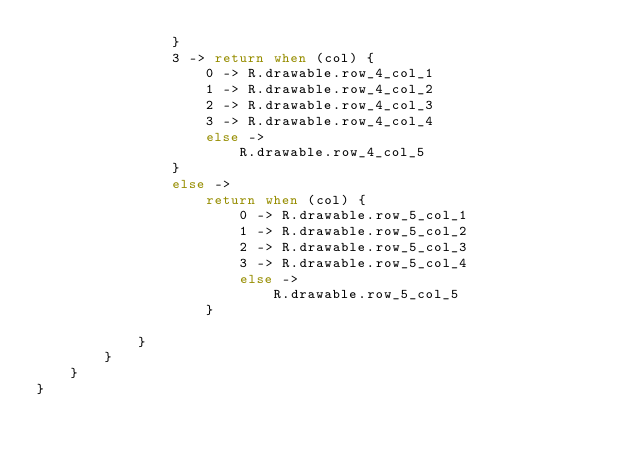<code> <loc_0><loc_0><loc_500><loc_500><_Kotlin_>                }
                3 -> return when (col) {
                    0 -> R.drawable.row_4_col_1
                    1 -> R.drawable.row_4_col_2
                    2 -> R.drawable.row_4_col_3
                    3 -> R.drawable.row_4_col_4
                    else ->
                        R.drawable.row_4_col_5
                }
                else ->
                    return when (col) {
                        0 -> R.drawable.row_5_col_1
                        1 -> R.drawable.row_5_col_2
                        2 -> R.drawable.row_5_col_3
                        3 -> R.drawable.row_5_col_4
                        else ->
                            R.drawable.row_5_col_5
                    }

            }
        }
    }
}</code> 